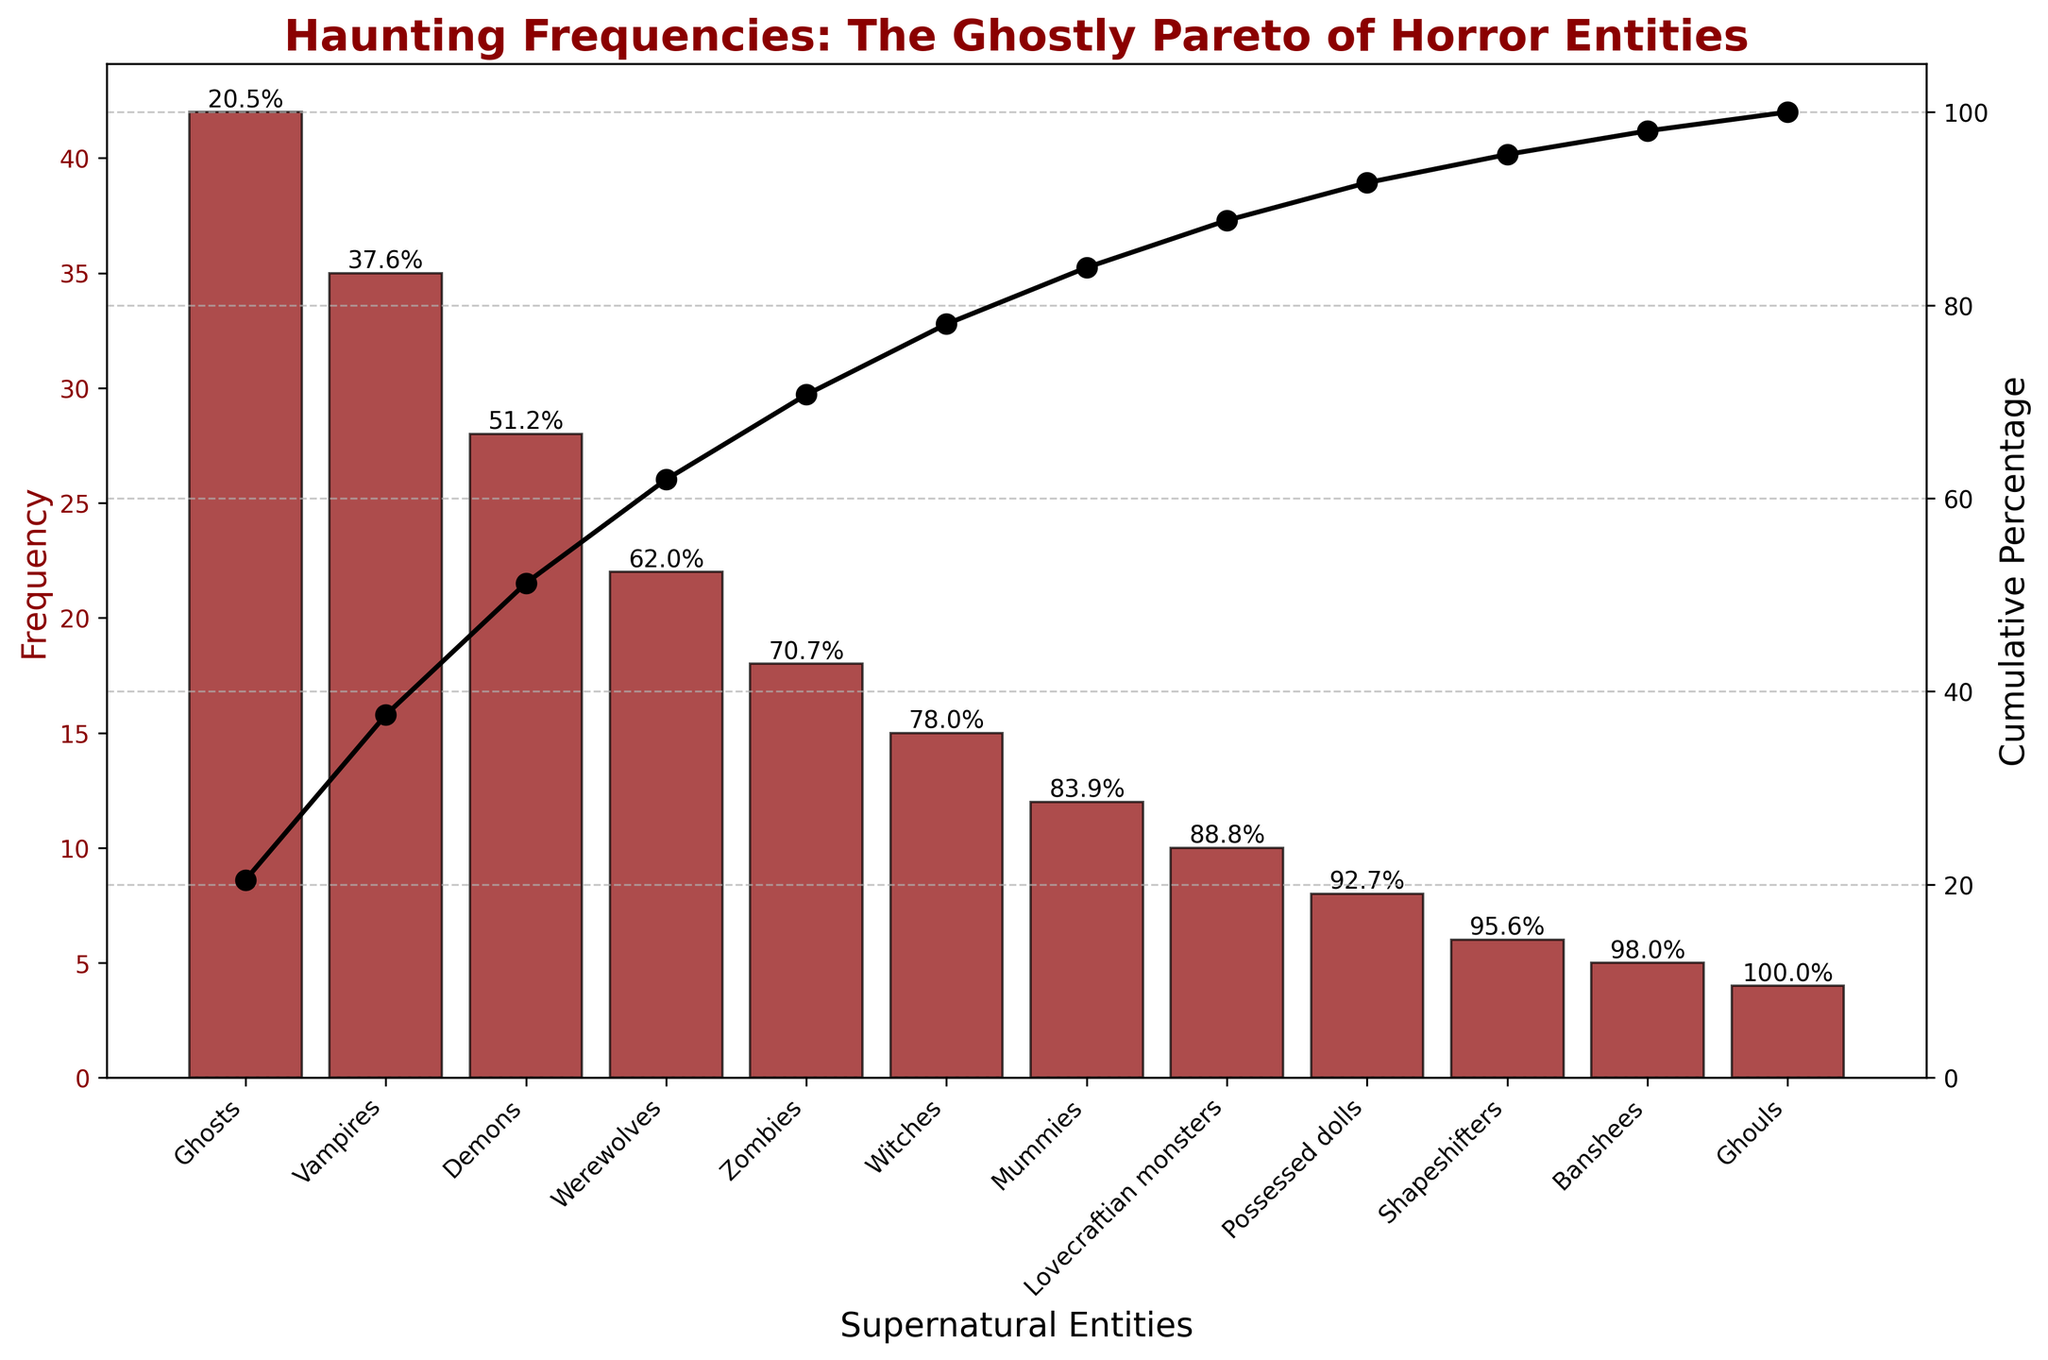How many supernatural entities are listed in the chart? The x-axis shows each supernatural entity as a category. Counting the labels on the x-axis gives us the number of entities.
Answer: 12 Which supernatural entity has the highest frequency? The tallest bar in the bar chart indicates the entity with the highest frequency.
Answer: Ghosts What's the cumulative percentage after the top three entities? Calculate the cumulative percentage of the top three entities by adding Ghosts (42), Vampires (35), and Demons (28) and then looking at the cumulative percentage line for the third entity.
Answer: 70.5% How many entities have a frequency less than 10? The y-axis shows the frequency. Counting the bars with their height under the 10-unit mark provides the answer.
Answer: 3 Which entity ranks 5th in terms of frequency? The bars are arranged in descending order of frequency. Counting down to the fifth bar gives us the entity.
Answer: Zombies What is the frequency difference between the most common and the least common entity? Subtract the frequency of the least common entity (Ghouls, 4) from the frequency of the most common entity (Ghosts, 42).
Answer: 38 What percentage of the total frequency is accounted for by Werewolves and Zombies together? Add the frequencies of Werewolves (22) and Zombies (18) and divide by the total frequency sum, then multiply by 100.
Answer: 21.7% Do ghosts and vampires together make up more than half of the total frequencies? Add the frequencies of Ghosts (42) and Vampires (35). Then, find their sum as a percentage of the total frequency (42 + 35) / 205 * 100.
Answer: Yes, 37.6% Which entity is just above Mummies in terms of frequency? In descending order, find the entity that comes right before Mummies (12).
Answer: Witches At what frequency does the cumulative percentage exceed 50%? Track the cumulative percentage line and identify the frequency value where it first crosses 50%.
Answer: 15 (between Demons and Werewolves) 